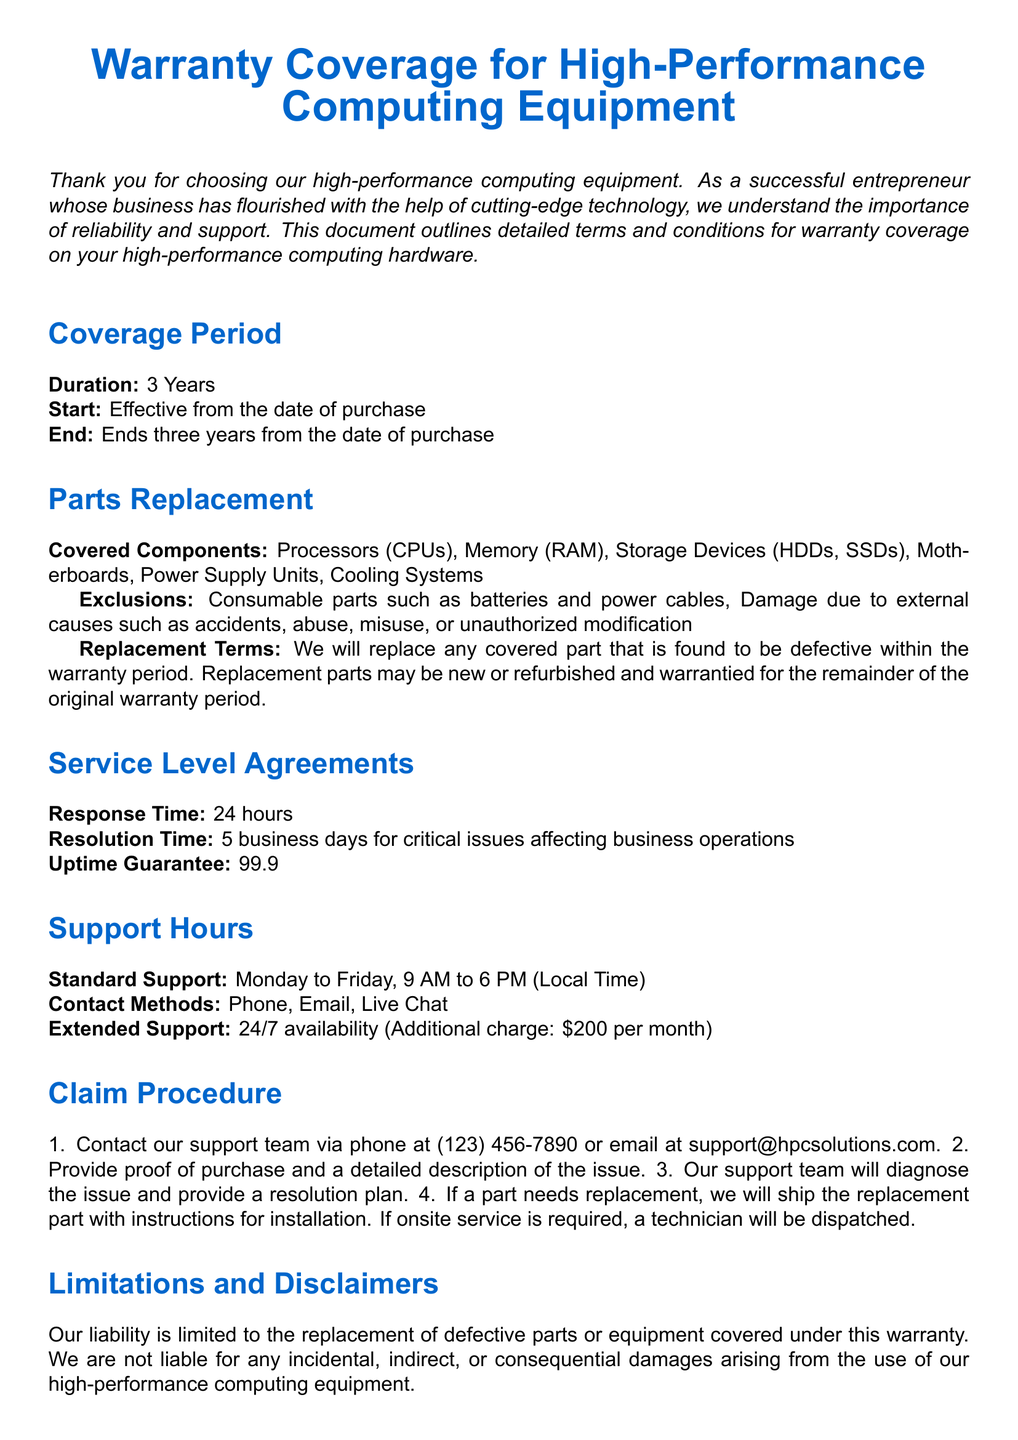What is the warranty coverage period? The warranty coverage period lasts for three years, starting from the date of purchase.
Answer: 3 Years What is the uptime guarantee? The document states that the uptime guarantee is part of the service commitment provided to customers.
Answer: 99.9% What are the standard support hours? The standard support hours are specified in the document under the Support Hours section.
Answer: Monday to Friday, 9 AM to 6 PM What type of parts are excluded from the warranty? Exclusions to coverage include specific parts that are classified as consumable and other categories mentioned.
Answer: Batteries and power cables What is the response time for support? The document outlines a specific time frame for how quickly support will respond to issues.
Answer: 24 hours What should you provide when contacting support? The document specifies necessary information to be given when reaching out for support in the Claim Procedure section.
Answer: Proof of purchase and a detailed description of the issue What is the additional charge for extended support? The document indicates that there is an extra fee associated with extending support past standard hours.
Answer: $200 per month What happens after claiming replacement? The document describes actions taken once a part needs to be replaced during the claim process.
Answer: Replacement part will be shipped with installation instructions What is the resolution time for critical issues? Critical issues have a dedicated resolution timeframe mentioned in the Service Level Agreements.
Answer: 5 business days 